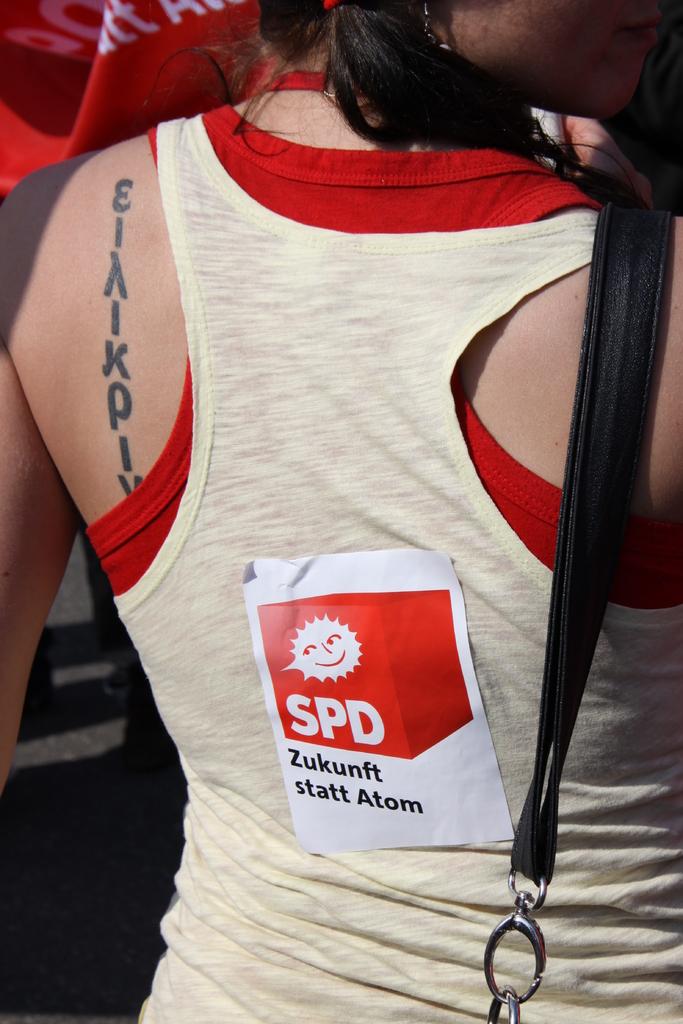What three letters are in the red box?
Your answer should be compact. Spd. 